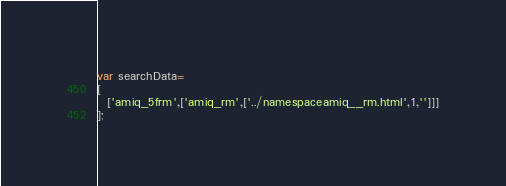Convert code to text. <code><loc_0><loc_0><loc_500><loc_500><_JavaScript_>var searchData=
[
  ['amiq_5frm',['amiq_rm',['../namespaceamiq__rm.html',1,'']]]
];
</code> 